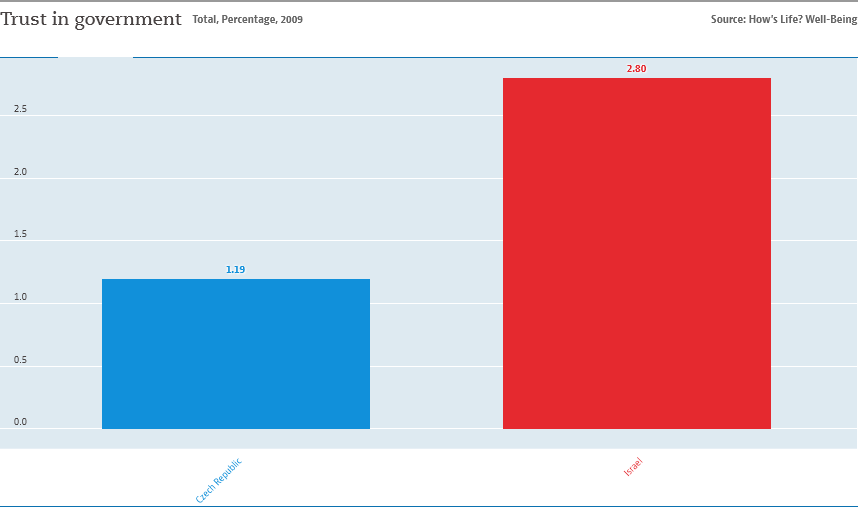Mention a couple of crucial points in this snapshot. The two bars have a difference of 1.61... There are two bars in the chart. 